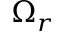<formula> <loc_0><loc_0><loc_500><loc_500>\Omega _ { r }</formula> 